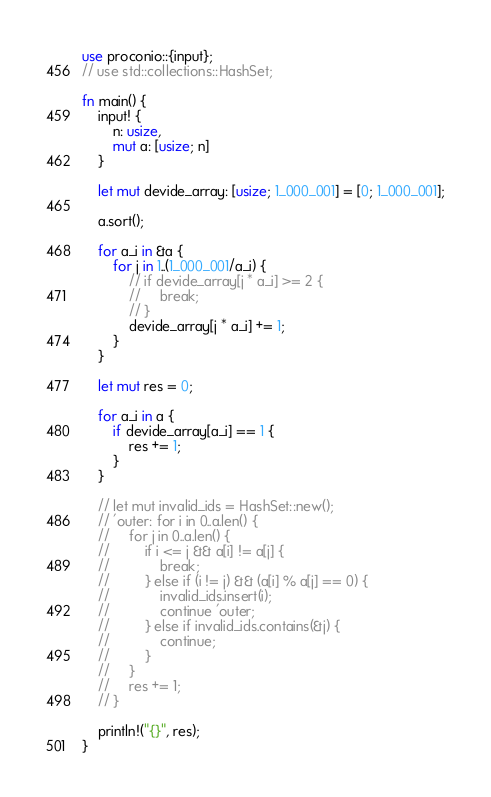Convert code to text. <code><loc_0><loc_0><loc_500><loc_500><_Rust_>use proconio::{input};
// use std::collections::HashSet;

fn main() {
    input! {
        n: usize,
        mut a: [usize; n]
    }

    let mut devide_array: [usize; 1_000_001] = [0; 1_000_001];

    a.sort();

    for a_i in &a {
        for j in 1..(1_000_001/a_i) {
            // if devide_array[j * a_i] >= 2 {
            //     break;
            // }
            devide_array[j * a_i] += 1;
        }
    }

    let mut res = 0;

    for a_i in a {
        if devide_array[a_i] == 1 {
            res += 1;
        }
    }

    // let mut invalid_ids = HashSet::new();
    // 'outer: for i in 0..a.len() {
    //     for j in 0..a.len() {
    //         if i <= j && a[i] != a[j] {
    //             break;
    //         } else if (i != j) && (a[i] % a[j] == 0) {
    //             invalid_ids.insert(i);
    //             continue 'outer;
    //         } else if invalid_ids.contains(&j) {
    //             continue;
    //         }
    //     }
    //     res += 1;
    // }

    println!("{}", res);
}
</code> 